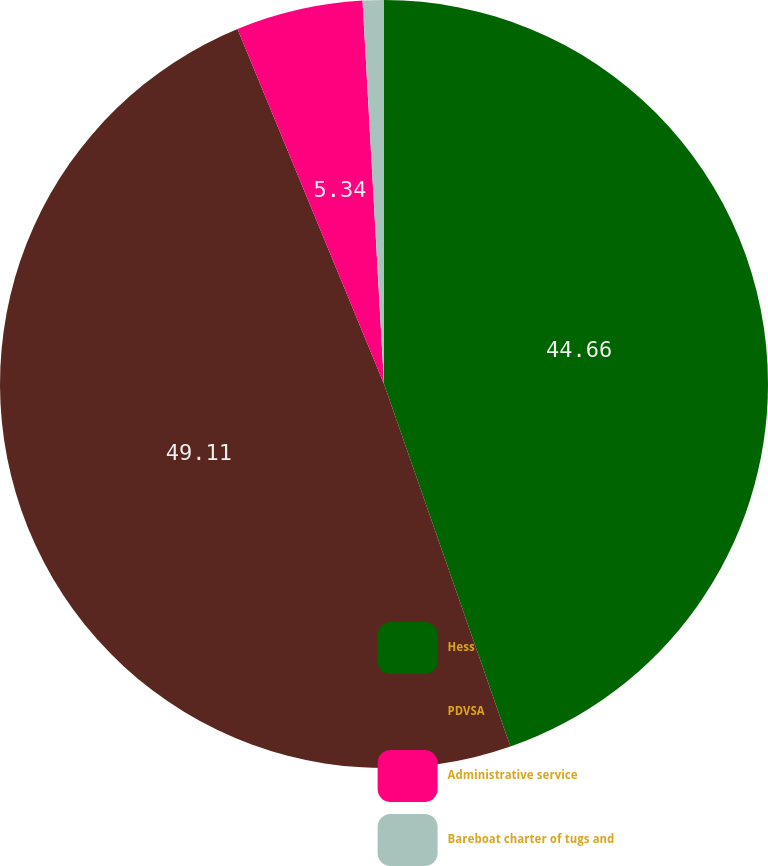Convert chart. <chart><loc_0><loc_0><loc_500><loc_500><pie_chart><fcel>Hess<fcel>PDVSA<fcel>Administrative service<fcel>Bareboat charter of tugs and<nl><fcel>44.66%<fcel>49.11%<fcel>5.34%<fcel>0.89%<nl></chart> 